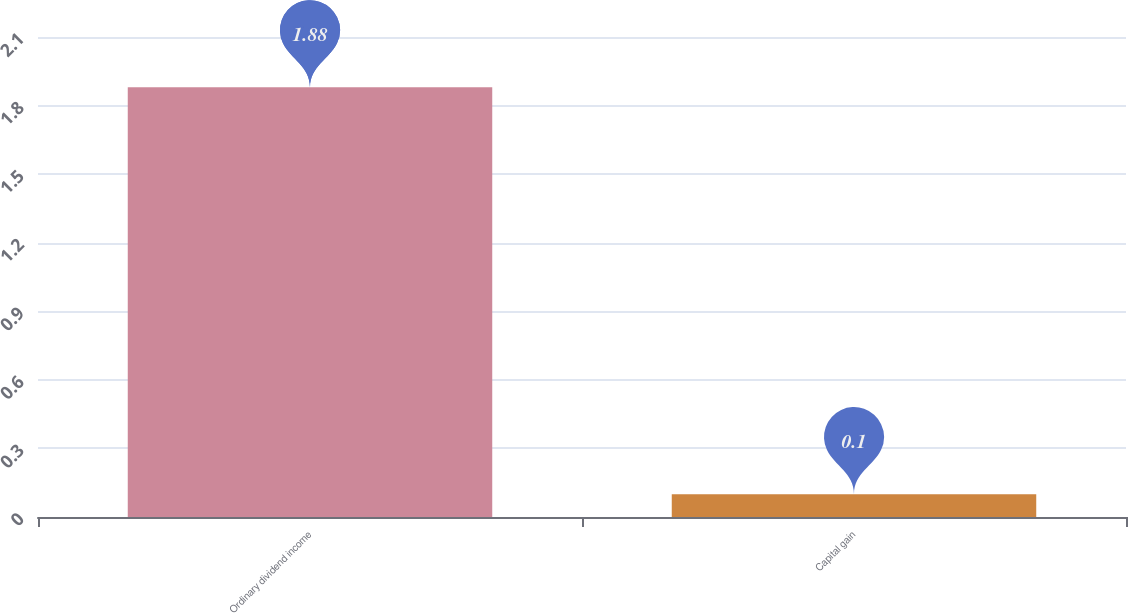<chart> <loc_0><loc_0><loc_500><loc_500><bar_chart><fcel>Ordinary dividend income<fcel>Capital gain<nl><fcel>1.88<fcel>0.1<nl></chart> 